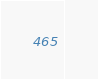<code> <loc_0><loc_0><loc_500><loc_500><_SQL_>
</code> 